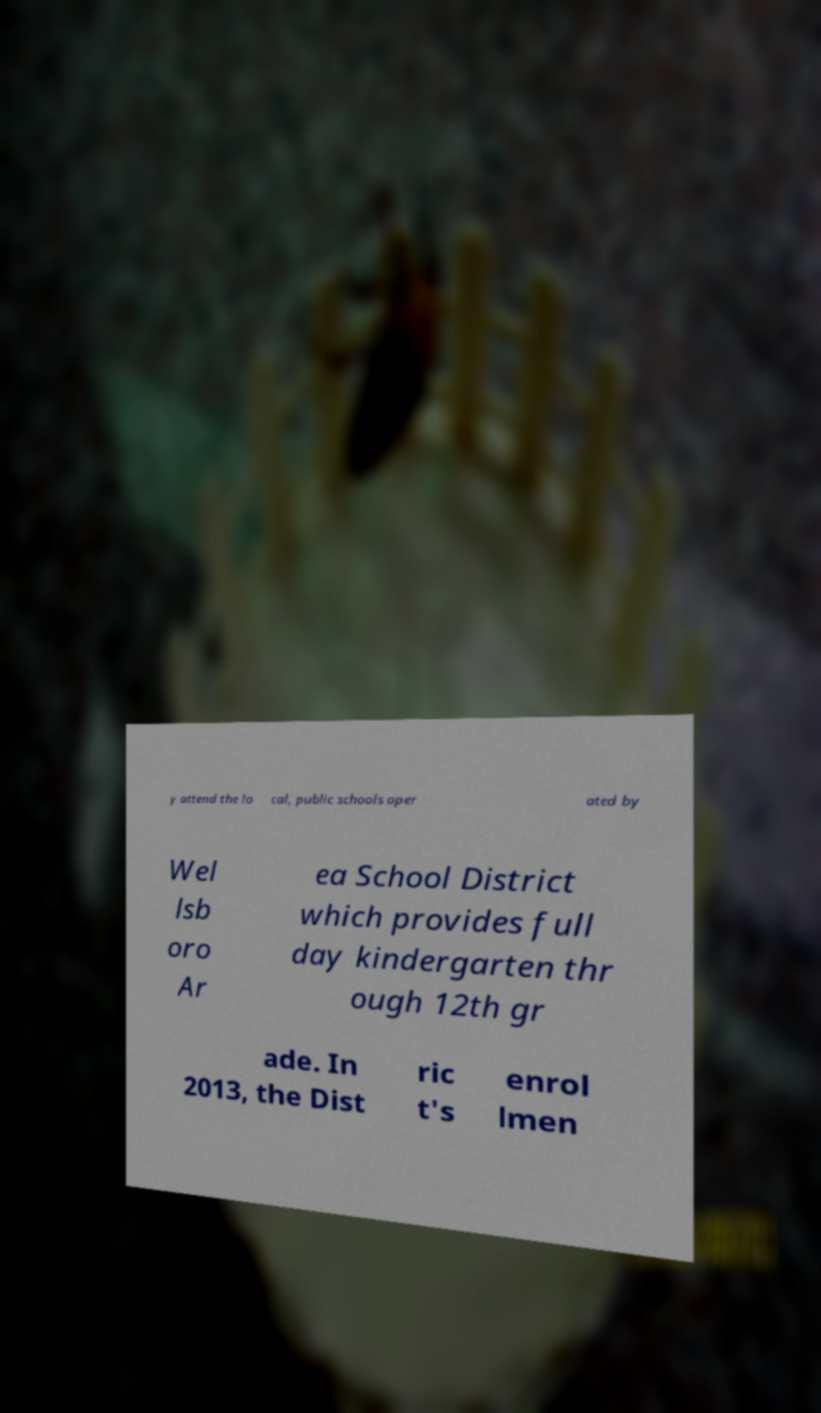Could you assist in decoding the text presented in this image and type it out clearly? y attend the lo cal, public schools oper ated by Wel lsb oro Ar ea School District which provides full day kindergarten thr ough 12th gr ade. In 2013, the Dist ric t's enrol lmen 